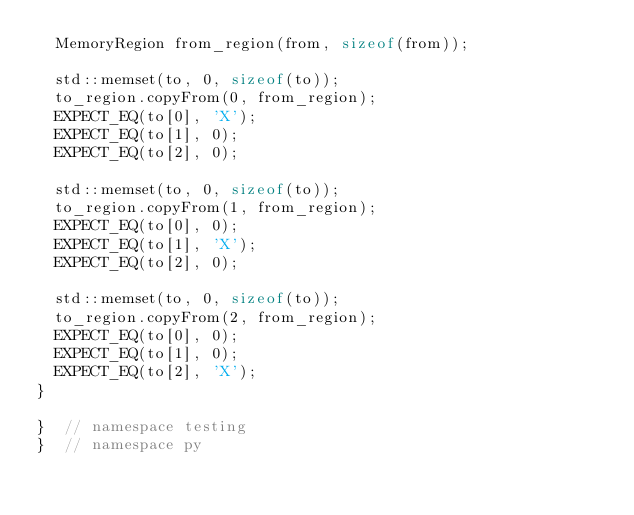<code> <loc_0><loc_0><loc_500><loc_500><_C++_>  MemoryRegion from_region(from, sizeof(from));

  std::memset(to, 0, sizeof(to));
  to_region.copyFrom(0, from_region);
  EXPECT_EQ(to[0], 'X');
  EXPECT_EQ(to[1], 0);
  EXPECT_EQ(to[2], 0);

  std::memset(to, 0, sizeof(to));
  to_region.copyFrom(1, from_region);
  EXPECT_EQ(to[0], 0);
  EXPECT_EQ(to[1], 'X');
  EXPECT_EQ(to[2], 0);

  std::memset(to, 0, sizeof(to));
  to_region.copyFrom(2, from_region);
  EXPECT_EQ(to[0], 0);
  EXPECT_EQ(to[1], 0);
  EXPECT_EQ(to[2], 'X');
}

}  // namespace testing
}  // namespace py
</code> 